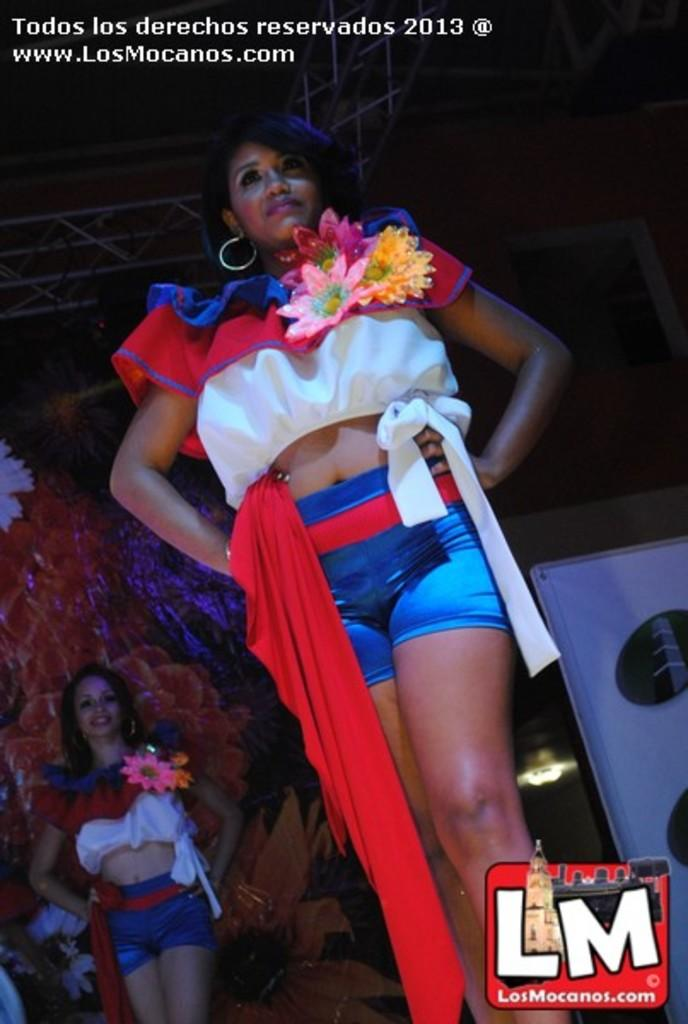<image>
Offer a succinct explanation of the picture presented. A photo of two women wearing blue shorts and red and white shirts with flowers on them is watermarked for LosMocanos.com 